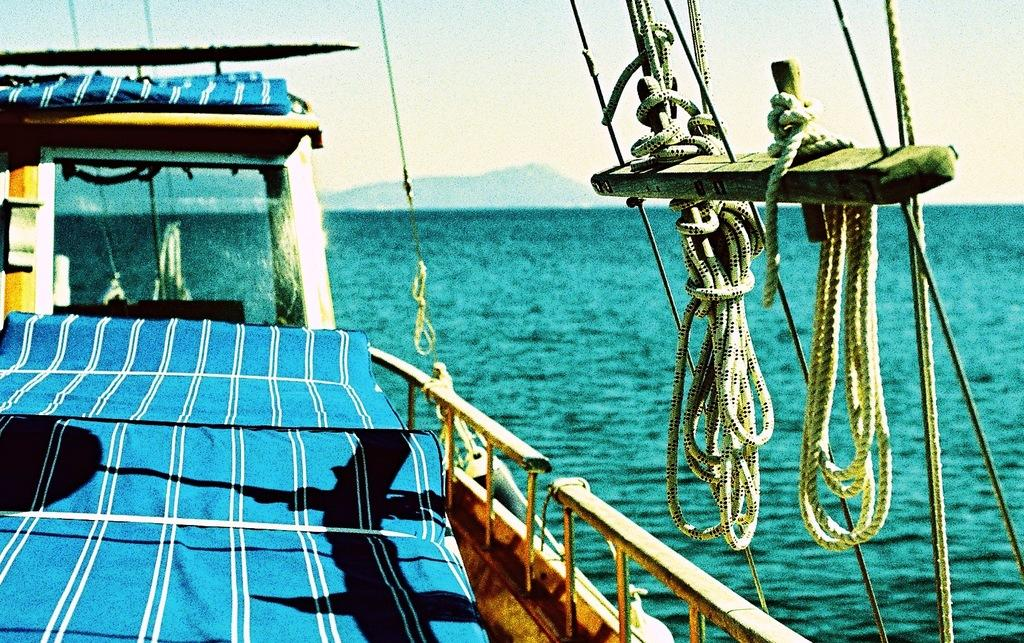What is the main subject of the image? The main subject of the image is a ship. Where is the ship located in the image? The ship is on water in the image. What other objects can be seen in the image? There are threads visible in the image. What can be seen in the background of the image? There are mountains and the sky visible in the background of the image. How many trees are visible on the ship in the image? There are no trees present on the ship in the image. What type of stove is being used on the ship in the image? There is no stove present on the ship in the image. 